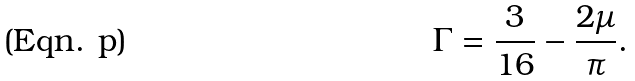Convert formula to latex. <formula><loc_0><loc_0><loc_500><loc_500>\Gamma = \frac { 3 } { 1 6 } - \frac { 2 \mu } { \pi } .</formula> 